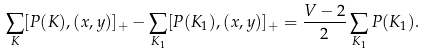Convert formula to latex. <formula><loc_0><loc_0><loc_500><loc_500>\sum _ { K } [ P ( K ) , ( x , y ) ] _ { + } - \sum _ { K _ { 1 } } [ P ( K _ { 1 } ) , ( x , y ) ] _ { + } = \frac { V - 2 } { 2 } \sum _ { K _ { 1 } } P ( K _ { 1 } ) .</formula> 